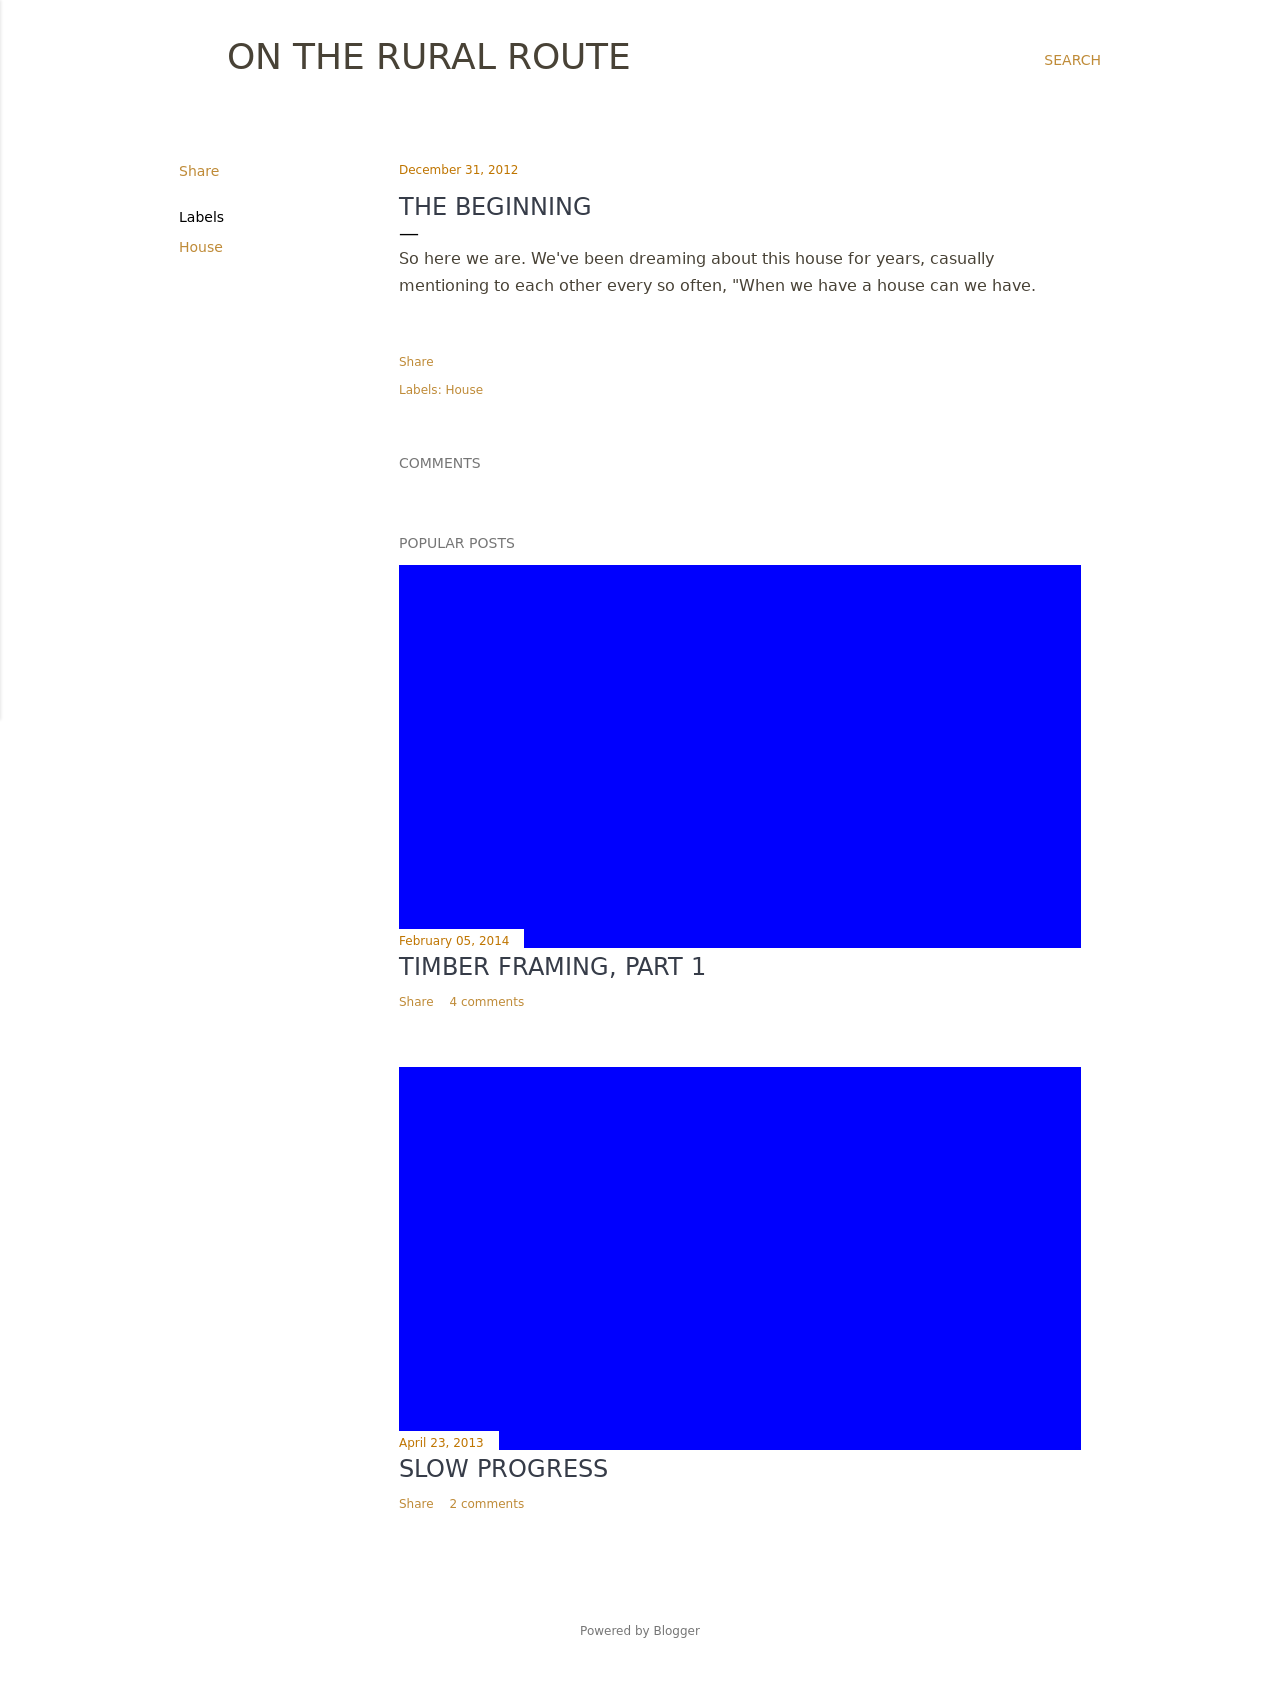How could I design the navigation to complement this blog layout? A simple top navigation bar would complement the blog's minimalistic style effectively. Use a horizontal menu with links to major sections of your site, styled in plain text against a white or light grey background. Consider adding a hover effect, such as a color change or underline, to indicate which section the user is currently viewing, maintaining the site's elegant aesthetics while improving usability. 